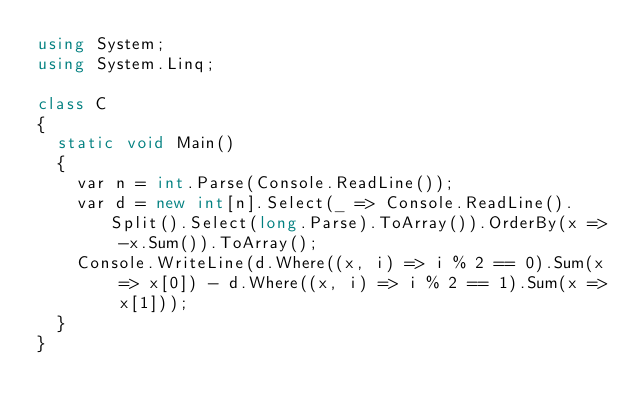<code> <loc_0><loc_0><loc_500><loc_500><_C#_>using System;
using System.Linq;

class C
{
	static void Main()
	{
		var n = int.Parse(Console.ReadLine());
		var d = new int[n].Select(_ => Console.ReadLine().Split().Select(long.Parse).ToArray()).OrderBy(x => -x.Sum()).ToArray();
		Console.WriteLine(d.Where((x, i) => i % 2 == 0).Sum(x => x[0]) - d.Where((x, i) => i % 2 == 1).Sum(x => x[1]));
	}
}
</code> 